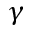Convert formula to latex. <formula><loc_0><loc_0><loc_500><loc_500>\gamma</formula> 